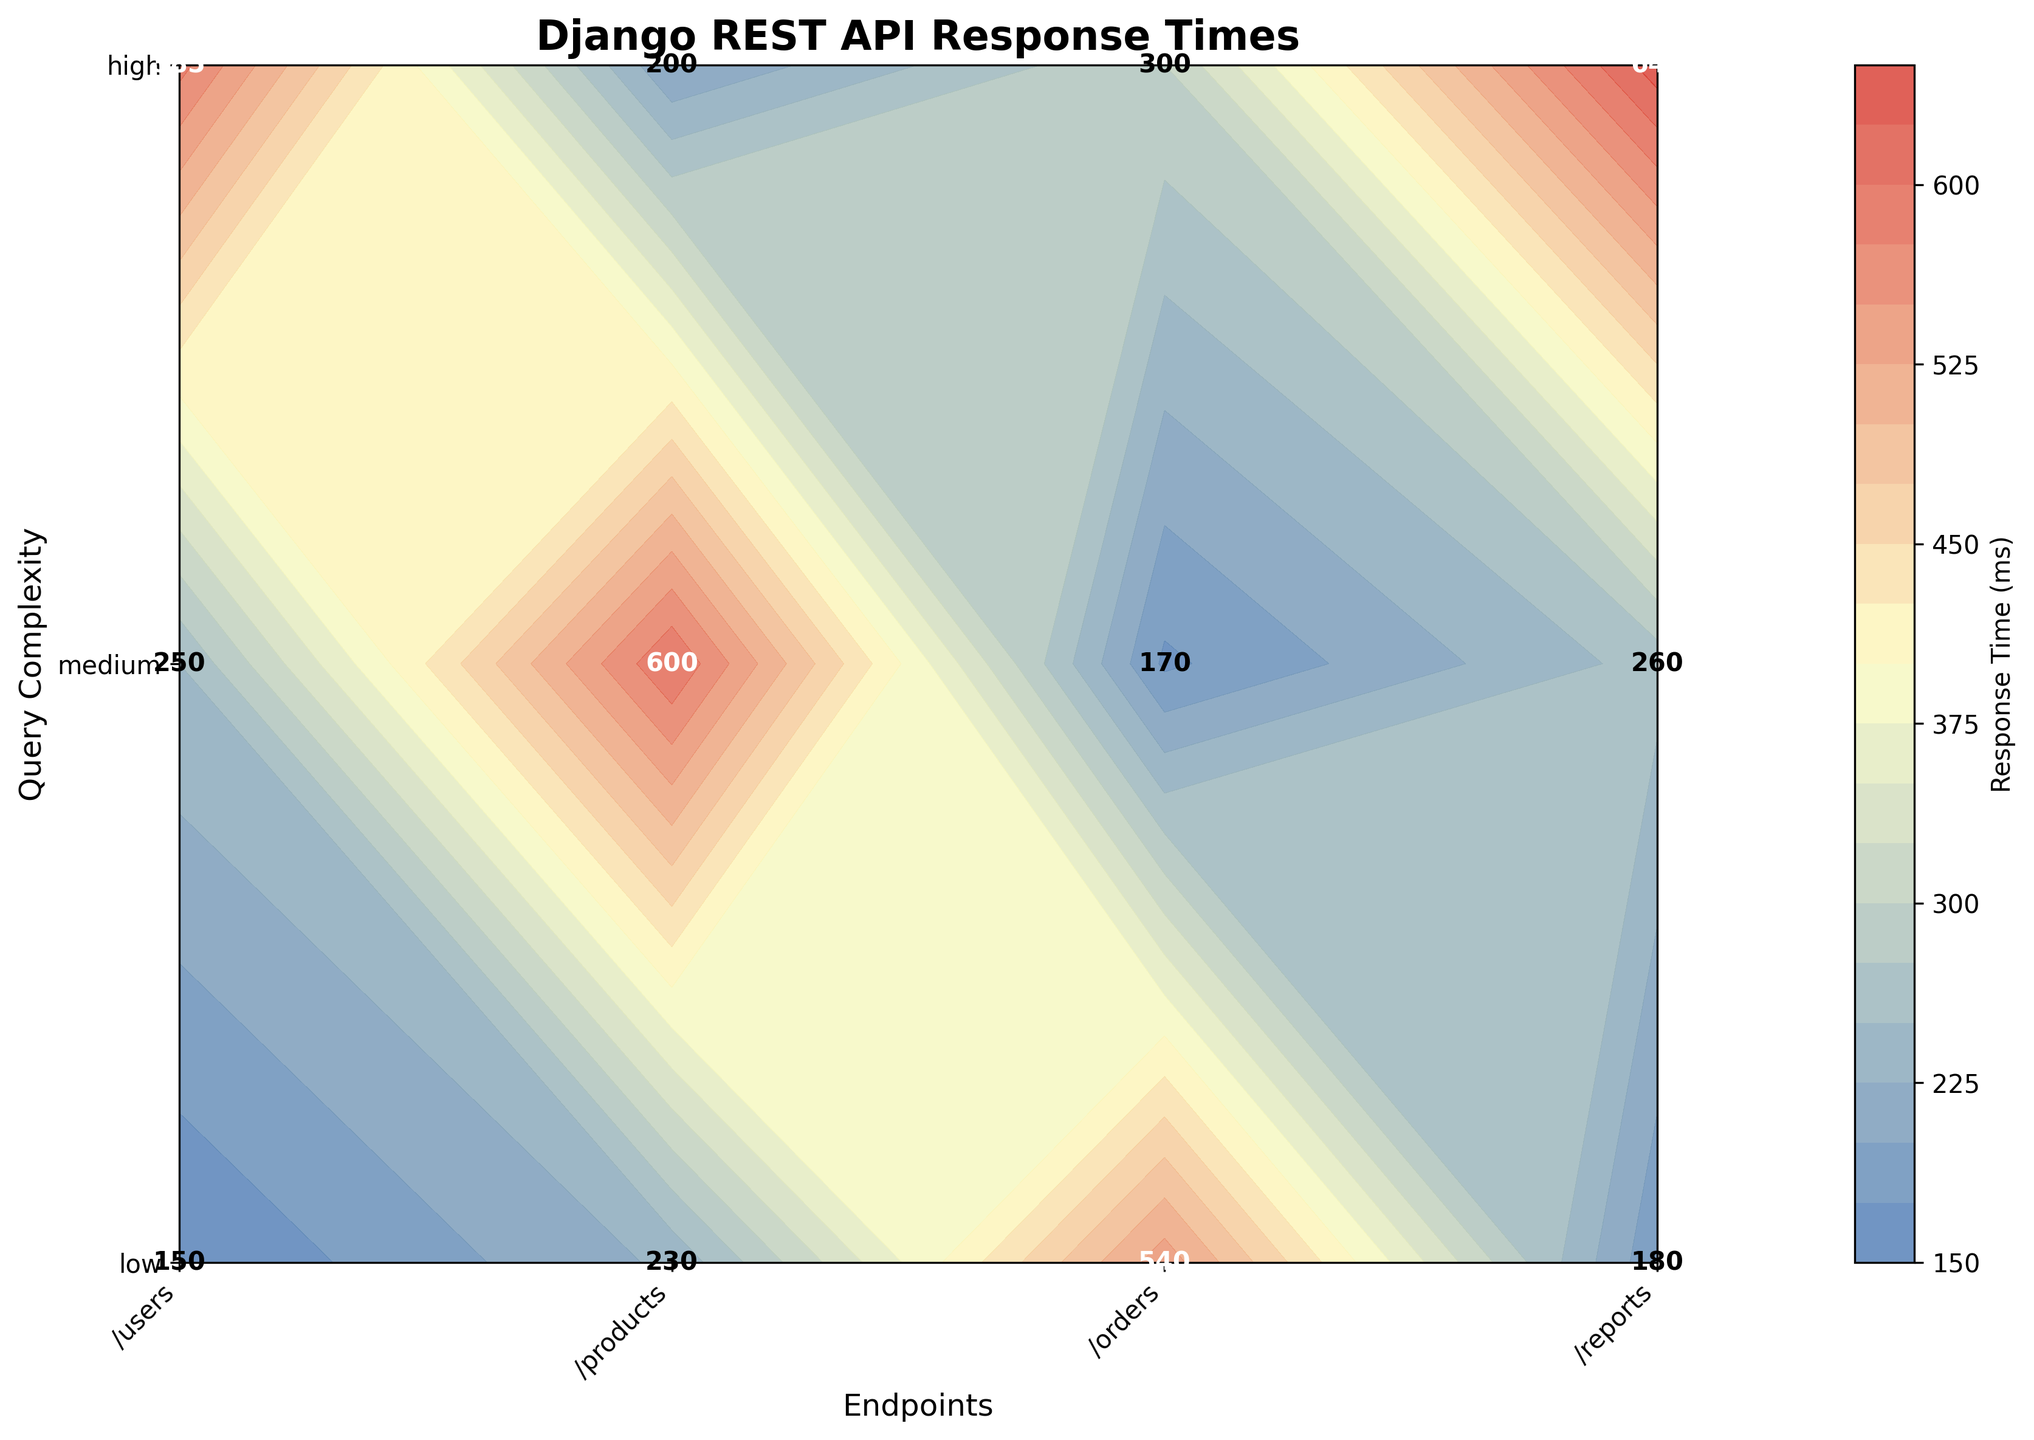What is the title of the plot? The title of the plot is displayed at the top of the figure.
Answer: Django REST API Response Times How many different endpoints are represented in the plot? The endpoints are labeled on the x-axis of the plot: '/users,' '/products,' '/orders,' and '/reports.' Count these labels to get the number of endpoints.
Answer: 4 What are the three levels of query complexity? The query complexities are labeled on the y-axis of the plot as 'low,' 'medium,' and 'high.'
Answer: Low, Medium, High Which endpoint and query complexity combination has the highest response time? Identify the combination with the maximum response time value. In this case, 'reports' with 'high' query complexity has the value of 640 ms.
Answer: Reports with high complexity What is the response time for the '/products' endpoint with 'medium' complexity? Locate the '/products' endpoint on the x-axis and the 'medium' complexity on the y-axis. Find the value at their intersection, which is 250 ms.
Answer: 250 ms By how much does the response time for '/users' with 'high' complexity exceed that for 'medium' complexity? Find the response times for '/users' at 'high' and 'medium' complexity, which are 540 ms and 230 ms, respectively. Subtract the medium complexity value from the high complexity value: 540 - 230.
Answer: 310 ms What is the average response time for the '/orders' endpoint across all query complexities? Find the response times for '/orders' at 'low,' 'medium,' and 'high' complexities, which are 170 ms, 260 ms, and 585 ms, respectively. Compute the average: (170 + 260 + 585) / 3.
Answer: 338.3 ms Compare the response times for 'low' query complexity across all endpoints. Which endpoint is the slowest? Locate the 'low' complexity row on the plot and compare the values for all endpoints: '/reports' has the highest value (200 ms) among them.
Answer: Reports Is there any endpoint where the response time decreases with increasing query complexity? Follow the response times for each endpoint from 'low' to 'medium' to 'high' complexities. Verify if any endpoint's response time decreases with increasing complexity. None of the endpoints exhibit this behavior.
Answer: No What color represents the highest response times in the plot? The color map used in the plot transitions from a specific color at the low end to another at the high end. The highest response times are represented by a dark red color based on the color legend.
Answer: Dark red 